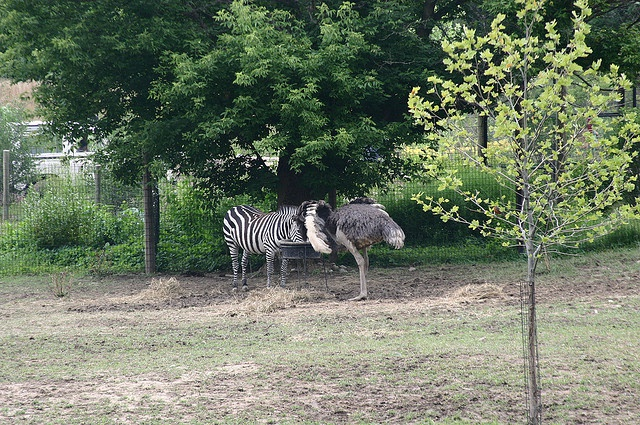Describe the objects in this image and their specific colors. I can see bird in olive, gray, darkgray, black, and lightgray tones and zebra in olive, black, gray, white, and darkgray tones in this image. 